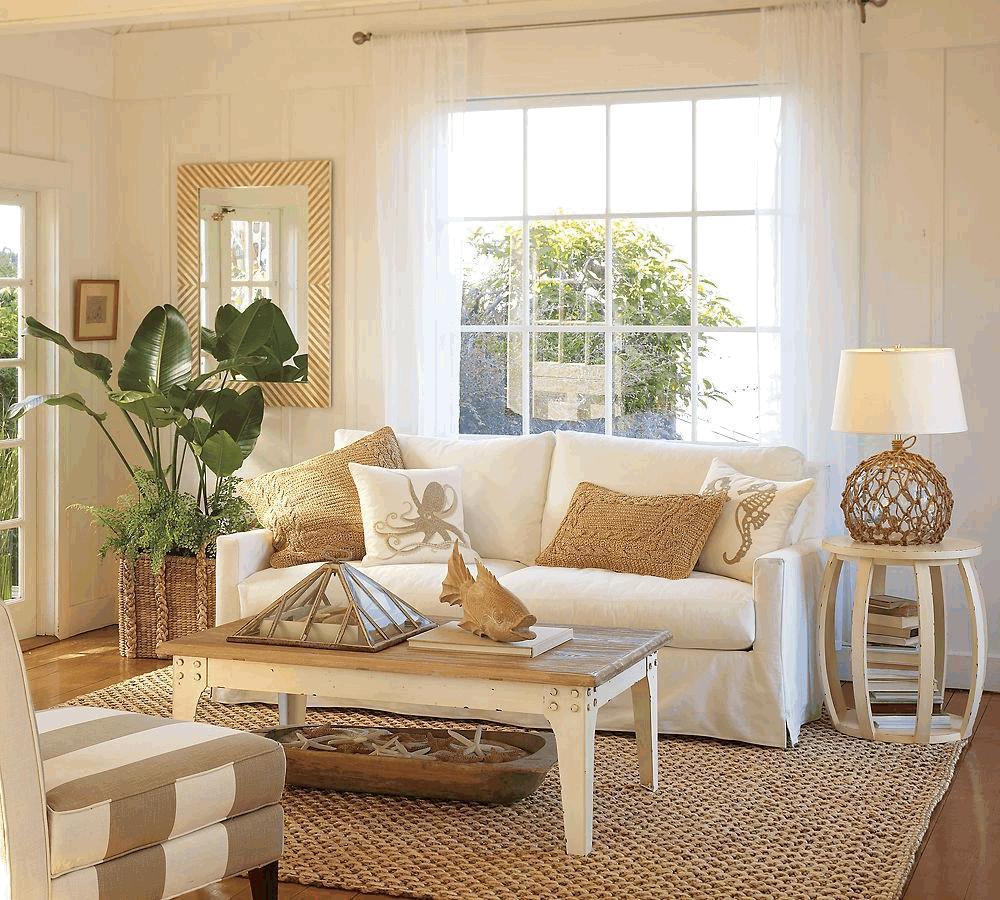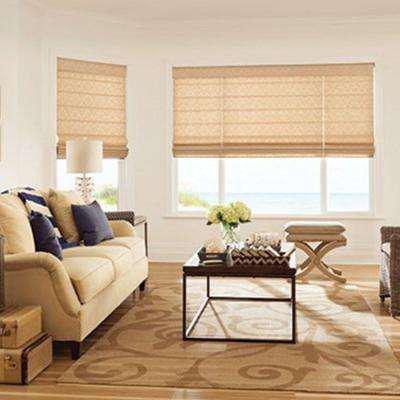The first image is the image on the left, the second image is the image on the right. Analyze the images presented: Is the assertion "The left and right image contains the same number of windows." valid? Answer yes or no. Yes. The first image is the image on the left, the second image is the image on the right. Given the left and right images, does the statement "The right image features windows covered by at least one dark brown shade." hold true? Answer yes or no. No. 